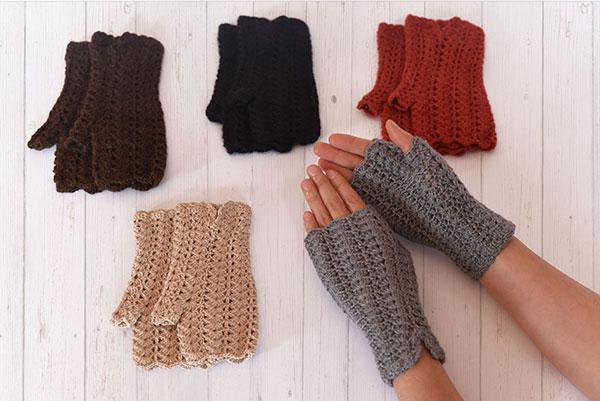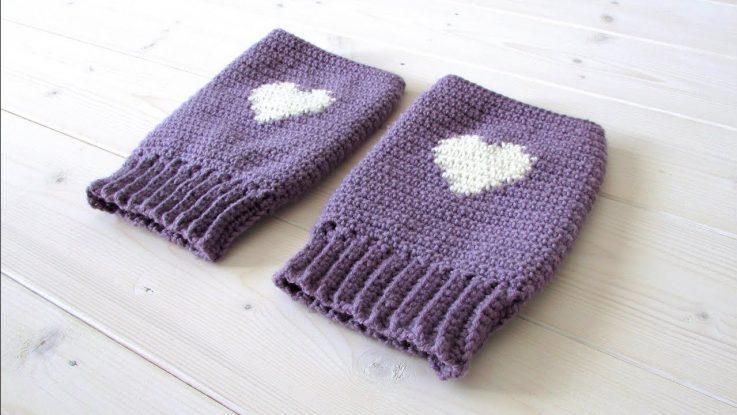The first image is the image on the left, the second image is the image on the right. Evaluate the accuracy of this statement regarding the images: "At least one pair of hand warmers is dark red.". Is it true? Answer yes or no. Yes. 